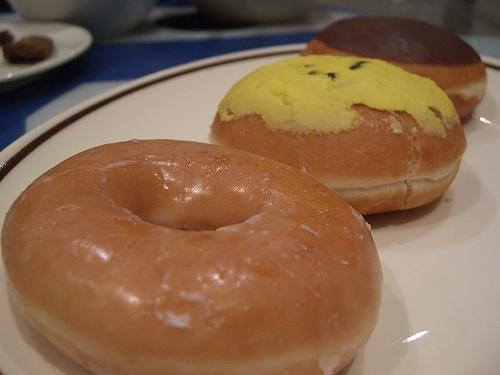How many different types of doughnuts are there?
Give a very brief answer. 3. How many doughnuts are there?
Give a very brief answer. 3. How many varieties of donuts is there?
Give a very brief answer. 3. How many donuts are in the picture?
Give a very brief answer. 3. How many people are standing?
Give a very brief answer. 0. 